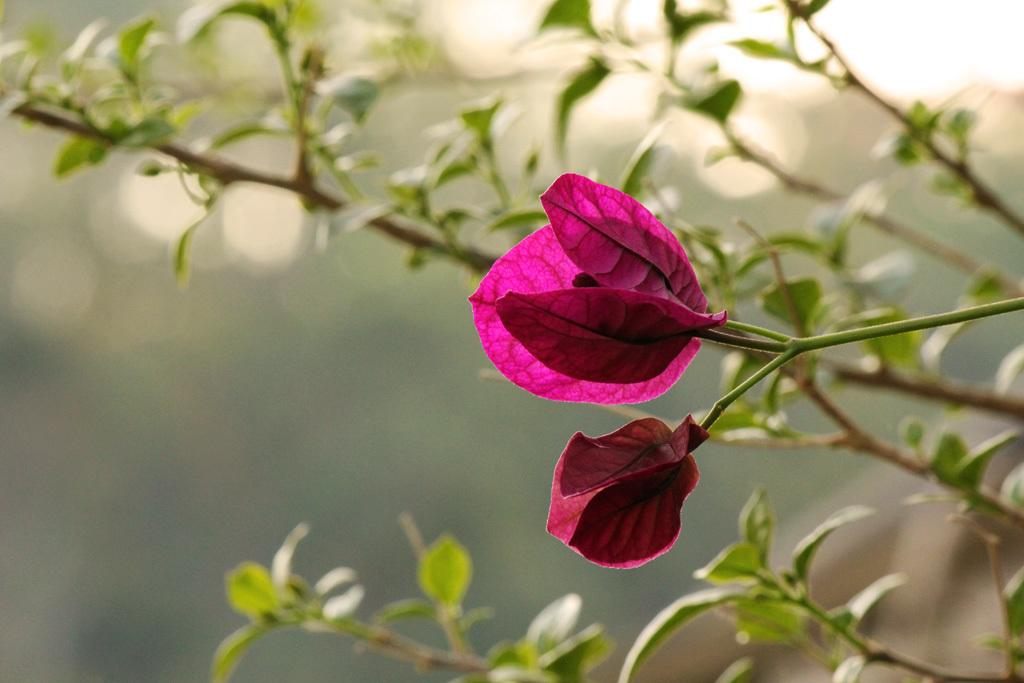How many flowers can be seen in the image? There are two flowers in the image. What color are the flowers? The flowers are pink in color. What other natural elements are present in the image? There is a tree with branches and leaves in the image. How would you describe the background of the image? The background of the image appears blurry. Where is the pail located in the image? There is no pail present in the image. What type of bedroom can be seen in the image? There is no bedroom present in the image; it features flowers and a tree. 